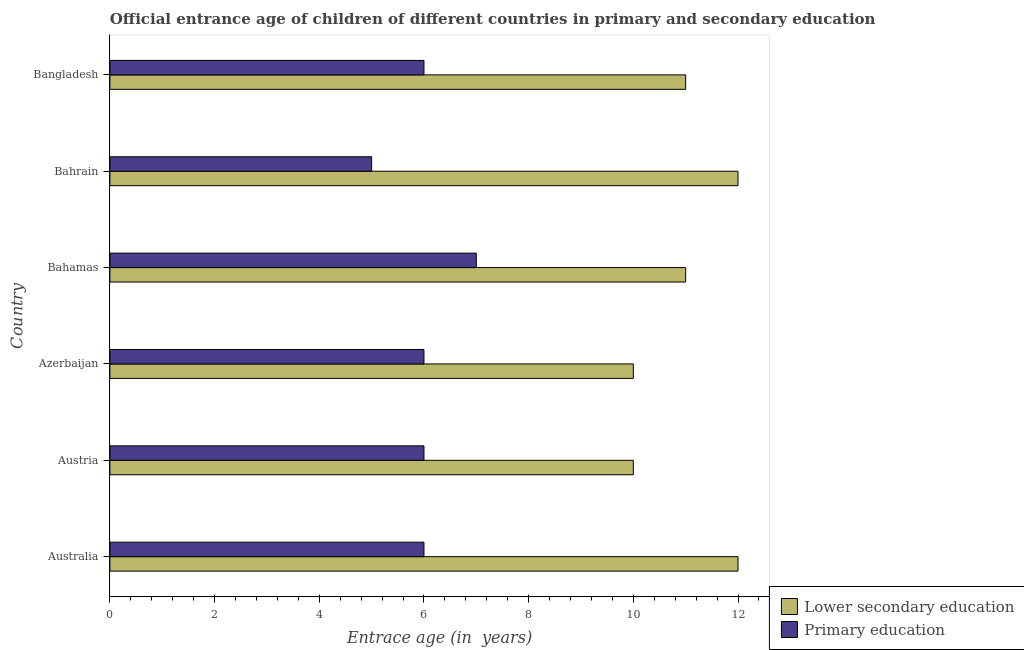How many different coloured bars are there?
Give a very brief answer. 2. Are the number of bars on each tick of the Y-axis equal?
Offer a terse response. Yes. What is the label of the 5th group of bars from the top?
Keep it short and to the point. Austria. In how many cases, is the number of bars for a given country not equal to the number of legend labels?
Your response must be concise. 0. Across all countries, what is the maximum entrance age of chiildren in primary education?
Provide a short and direct response. 7. Across all countries, what is the minimum entrance age of chiildren in primary education?
Ensure brevity in your answer.  5. In which country was the entrance age of children in lower secondary education maximum?
Make the answer very short. Australia. In which country was the entrance age of children in lower secondary education minimum?
Ensure brevity in your answer.  Austria. What is the total entrance age of children in lower secondary education in the graph?
Provide a succinct answer. 66. What is the difference between the entrance age of children in lower secondary education in Australia and the entrance age of chiildren in primary education in Bahrain?
Provide a short and direct response. 7. What is the difference between the entrance age of children in lower secondary education and entrance age of chiildren in primary education in Azerbaijan?
Provide a succinct answer. 4. In how many countries, is the entrance age of children in lower secondary education greater than 11.6 years?
Keep it short and to the point. 2. What is the ratio of the entrance age of chiildren in primary education in Australia to that in Bangladesh?
Offer a very short reply. 1. Is the entrance age of chiildren in primary education in Azerbaijan less than that in Bangladesh?
Your response must be concise. No. Is the difference between the entrance age of children in lower secondary education in Azerbaijan and Bahamas greater than the difference between the entrance age of chiildren in primary education in Azerbaijan and Bahamas?
Your response must be concise. No. What is the difference between the highest and the second highest entrance age of children in lower secondary education?
Keep it short and to the point. 0. What is the difference between the highest and the lowest entrance age of children in lower secondary education?
Your answer should be compact. 2. What does the 1st bar from the top in Australia represents?
Provide a succinct answer. Primary education. What does the 2nd bar from the bottom in Bahamas represents?
Your answer should be very brief. Primary education. How many bars are there?
Keep it short and to the point. 12. How many countries are there in the graph?
Ensure brevity in your answer.  6. Does the graph contain grids?
Give a very brief answer. No. Where does the legend appear in the graph?
Offer a terse response. Bottom right. How many legend labels are there?
Your response must be concise. 2. How are the legend labels stacked?
Your response must be concise. Vertical. What is the title of the graph?
Ensure brevity in your answer.  Official entrance age of children of different countries in primary and secondary education. Does "Public funds" appear as one of the legend labels in the graph?
Offer a very short reply. No. What is the label or title of the X-axis?
Make the answer very short. Entrace age (in  years). What is the Entrace age (in  years) in Primary education in Australia?
Your answer should be very brief. 6. What is the Entrace age (in  years) of Lower secondary education in Austria?
Your answer should be very brief. 10. What is the Entrace age (in  years) of Primary education in Azerbaijan?
Offer a terse response. 6. What is the Entrace age (in  years) in Lower secondary education in Bahrain?
Provide a succinct answer. 12. What is the Entrace age (in  years) of Primary education in Bahrain?
Make the answer very short. 5. What is the Entrace age (in  years) of Lower secondary education in Bangladesh?
Your answer should be very brief. 11. Across all countries, what is the minimum Entrace age (in  years) of Lower secondary education?
Make the answer very short. 10. Across all countries, what is the minimum Entrace age (in  years) in Primary education?
Your answer should be very brief. 5. What is the difference between the Entrace age (in  years) in Lower secondary education in Australia and that in Austria?
Keep it short and to the point. 2. What is the difference between the Entrace age (in  years) in Primary education in Australia and that in Austria?
Provide a short and direct response. 0. What is the difference between the Entrace age (in  years) of Primary education in Australia and that in Azerbaijan?
Provide a short and direct response. 0. What is the difference between the Entrace age (in  years) of Lower secondary education in Australia and that in Bahrain?
Your answer should be compact. 0. What is the difference between the Entrace age (in  years) in Primary education in Australia and that in Bahrain?
Provide a short and direct response. 1. What is the difference between the Entrace age (in  years) of Primary education in Australia and that in Bangladesh?
Offer a terse response. 0. What is the difference between the Entrace age (in  years) in Lower secondary education in Austria and that in Azerbaijan?
Offer a terse response. 0. What is the difference between the Entrace age (in  years) of Lower secondary education in Azerbaijan and that in Bahamas?
Ensure brevity in your answer.  -1. What is the difference between the Entrace age (in  years) in Lower secondary education in Azerbaijan and that in Bahrain?
Offer a terse response. -2. What is the difference between the Entrace age (in  years) of Primary education in Azerbaijan and that in Bangladesh?
Give a very brief answer. 0. What is the difference between the Entrace age (in  years) of Lower secondary education in Bahamas and that in Bahrain?
Keep it short and to the point. -1. What is the difference between the Entrace age (in  years) of Primary education in Bahamas and that in Bangladesh?
Your answer should be compact. 1. What is the difference between the Entrace age (in  years) of Lower secondary education in Bahrain and that in Bangladesh?
Offer a terse response. 1. What is the difference between the Entrace age (in  years) of Primary education in Bahrain and that in Bangladesh?
Ensure brevity in your answer.  -1. What is the difference between the Entrace age (in  years) of Lower secondary education in Australia and the Entrace age (in  years) of Primary education in Azerbaijan?
Offer a terse response. 6. What is the difference between the Entrace age (in  years) of Lower secondary education in Australia and the Entrace age (in  years) of Primary education in Bahrain?
Your response must be concise. 7. What is the difference between the Entrace age (in  years) in Lower secondary education in Australia and the Entrace age (in  years) in Primary education in Bangladesh?
Provide a short and direct response. 6. What is the difference between the Entrace age (in  years) of Lower secondary education in Austria and the Entrace age (in  years) of Primary education in Azerbaijan?
Your answer should be very brief. 4. What is the difference between the Entrace age (in  years) of Lower secondary education in Austria and the Entrace age (in  years) of Primary education in Bangladesh?
Give a very brief answer. 4. What is the difference between the Entrace age (in  years) in Lower secondary education in Azerbaijan and the Entrace age (in  years) in Primary education in Bahamas?
Your answer should be very brief. 3. What is the difference between the Entrace age (in  years) in Lower secondary education in Azerbaijan and the Entrace age (in  years) in Primary education in Bahrain?
Offer a very short reply. 5. What is the difference between the Entrace age (in  years) in Lower secondary education in Azerbaijan and the Entrace age (in  years) in Primary education in Bangladesh?
Make the answer very short. 4. What is the difference between the Entrace age (in  years) of Lower secondary education in Bahrain and the Entrace age (in  years) of Primary education in Bangladesh?
Your answer should be very brief. 6. What is the average Entrace age (in  years) in Primary education per country?
Ensure brevity in your answer.  6. What is the difference between the Entrace age (in  years) of Lower secondary education and Entrace age (in  years) of Primary education in Austria?
Your answer should be compact. 4. What is the difference between the Entrace age (in  years) in Lower secondary education and Entrace age (in  years) in Primary education in Bahrain?
Your answer should be compact. 7. What is the ratio of the Entrace age (in  years) in Lower secondary education in Australia to that in Austria?
Keep it short and to the point. 1.2. What is the ratio of the Entrace age (in  years) in Lower secondary education in Australia to that in Bahamas?
Offer a terse response. 1.09. What is the ratio of the Entrace age (in  years) in Primary education in Australia to that in Bahamas?
Provide a succinct answer. 0.86. What is the ratio of the Entrace age (in  years) of Lower secondary education in Australia to that in Bangladesh?
Keep it short and to the point. 1.09. What is the ratio of the Entrace age (in  years) in Primary education in Austria to that in Bahamas?
Provide a succinct answer. 0.86. What is the ratio of the Entrace age (in  years) in Primary education in Austria to that in Bahrain?
Make the answer very short. 1.2. What is the ratio of the Entrace age (in  years) of Lower secondary education in Azerbaijan to that in Bahamas?
Give a very brief answer. 0.91. What is the ratio of the Entrace age (in  years) of Primary education in Azerbaijan to that in Bahamas?
Keep it short and to the point. 0.86. What is the ratio of the Entrace age (in  years) in Primary education in Azerbaijan to that in Bahrain?
Your answer should be compact. 1.2. What is the ratio of the Entrace age (in  years) in Primary education in Azerbaijan to that in Bangladesh?
Your answer should be compact. 1. What is the ratio of the Entrace age (in  years) in Lower secondary education in Bahamas to that in Bahrain?
Provide a succinct answer. 0.92. What is the ratio of the Entrace age (in  years) of Lower secondary education in Bahamas to that in Bangladesh?
Offer a very short reply. 1. What is the ratio of the Entrace age (in  years) in Primary education in Bahamas to that in Bangladesh?
Your answer should be very brief. 1.17. What is the ratio of the Entrace age (in  years) in Lower secondary education in Bahrain to that in Bangladesh?
Make the answer very short. 1.09. What is the difference between the highest and the second highest Entrace age (in  years) in Primary education?
Offer a terse response. 1. What is the difference between the highest and the lowest Entrace age (in  years) in Lower secondary education?
Offer a terse response. 2. 